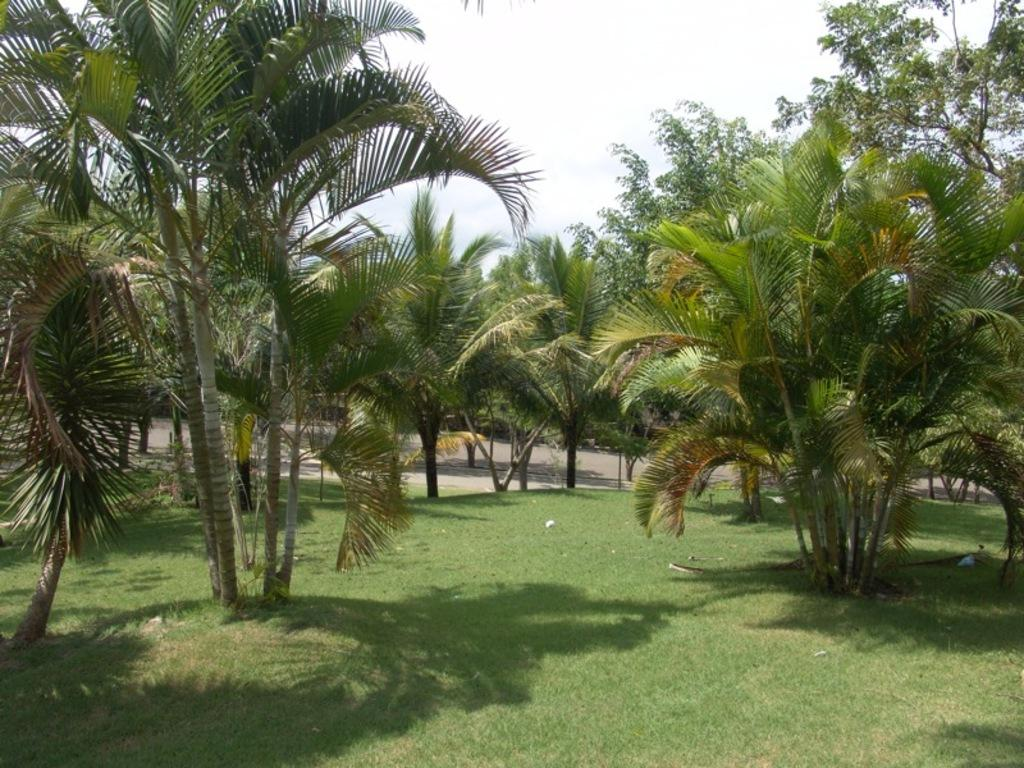What type of vegetation is present on the ground in the image? There is grass on the ground in the image. What other natural elements can be seen in the image? There are trees in the image. What can be seen in the distance in the image? There is a road visible in the background of the image. What is visible above the trees and road in the image? The sky is visible in the background of the image. What type of jelly is being used to decorate the trees in the image? There is no jelly present in the image, and the trees are not being decorated. 